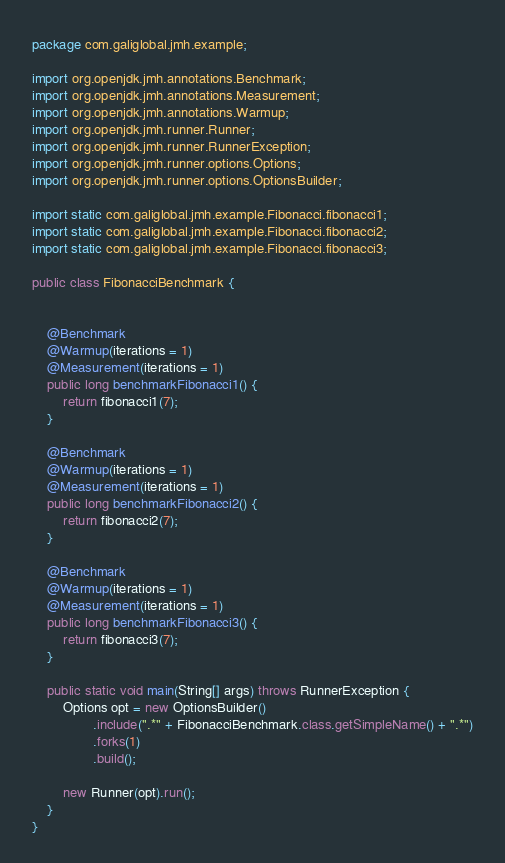Convert code to text. <code><loc_0><loc_0><loc_500><loc_500><_Java_>package com.galiglobal.jmh.example;

import org.openjdk.jmh.annotations.Benchmark;
import org.openjdk.jmh.annotations.Measurement;
import org.openjdk.jmh.annotations.Warmup;
import org.openjdk.jmh.runner.Runner;
import org.openjdk.jmh.runner.RunnerException;
import org.openjdk.jmh.runner.options.Options;
import org.openjdk.jmh.runner.options.OptionsBuilder;

import static com.galiglobal.jmh.example.Fibonacci.fibonacci1;
import static com.galiglobal.jmh.example.Fibonacci.fibonacci2;
import static com.galiglobal.jmh.example.Fibonacci.fibonacci3;

public class FibonacciBenchmark {


    @Benchmark
    @Warmup(iterations = 1)
    @Measurement(iterations = 1)
    public long benchmarkFibonacci1() {
        return fibonacci1(7);
    }

    @Benchmark
    @Warmup(iterations = 1)
    @Measurement(iterations = 1)
    public long benchmarkFibonacci2() {
        return fibonacci2(7);
    }

    @Benchmark
    @Warmup(iterations = 1)
    @Measurement(iterations = 1)
    public long benchmarkFibonacci3() {
        return fibonacci3(7);
    }

    public static void main(String[] args) throws RunnerException {
        Options opt = new OptionsBuilder()
                .include(".*" + FibonacciBenchmark.class.getSimpleName() + ".*")
                .forks(1)
                .build();

        new Runner(opt).run();
    }
}
</code> 